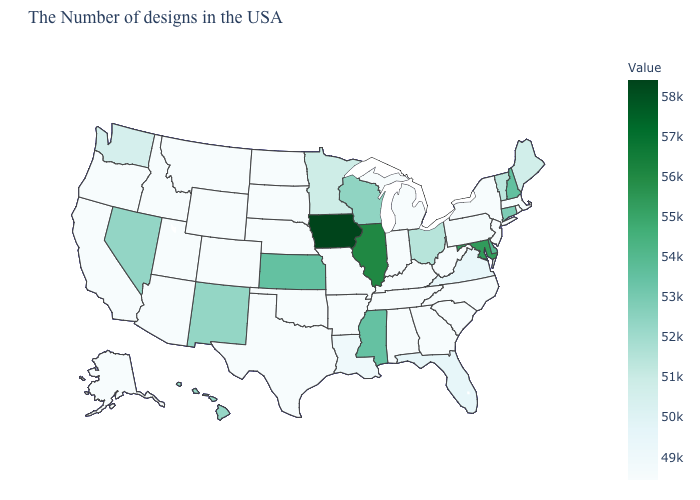Which states have the highest value in the USA?
Short answer required. Iowa. Which states have the lowest value in the MidWest?
Be succinct. Michigan, Indiana, Missouri, Nebraska, South Dakota, North Dakota. Which states hav the highest value in the South?
Keep it brief. Maryland. Does West Virginia have the lowest value in the South?
Quick response, please. Yes. 